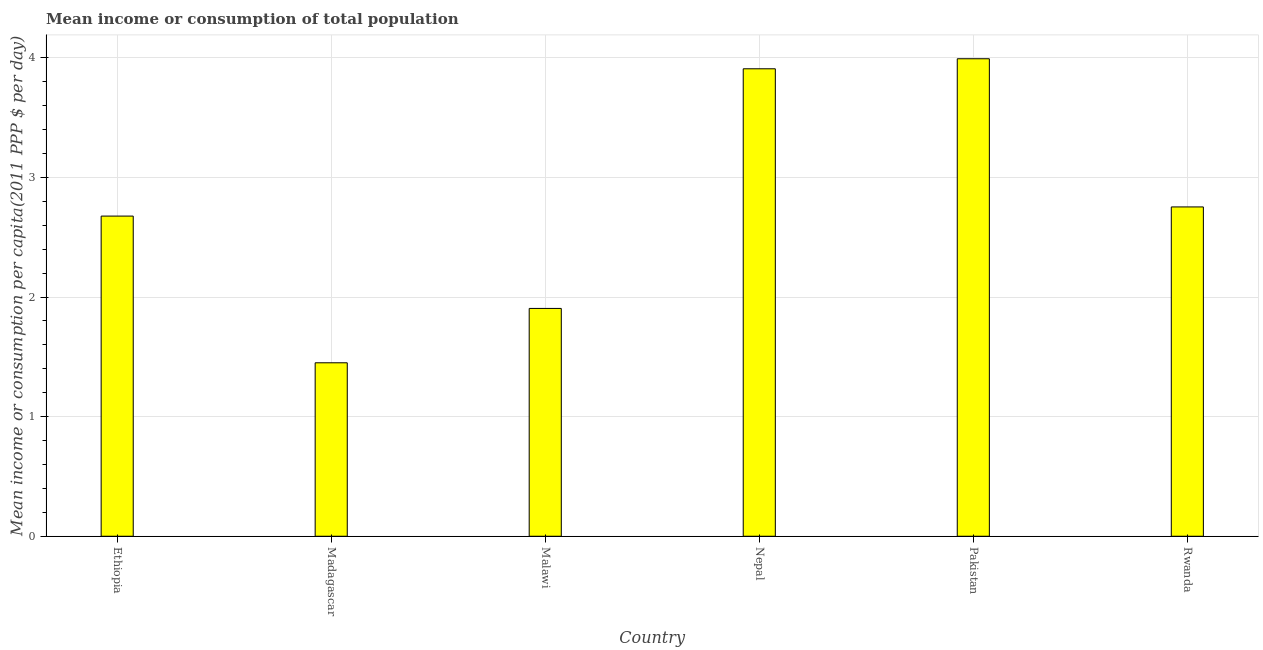Does the graph contain any zero values?
Make the answer very short. No. What is the title of the graph?
Provide a short and direct response. Mean income or consumption of total population. What is the label or title of the X-axis?
Give a very brief answer. Country. What is the label or title of the Y-axis?
Your answer should be very brief. Mean income or consumption per capita(2011 PPP $ per day). What is the mean income or consumption in Nepal?
Your response must be concise. 3.91. Across all countries, what is the maximum mean income or consumption?
Ensure brevity in your answer.  3.99. Across all countries, what is the minimum mean income or consumption?
Ensure brevity in your answer.  1.45. In which country was the mean income or consumption minimum?
Your answer should be compact. Madagascar. What is the sum of the mean income or consumption?
Ensure brevity in your answer.  16.69. What is the difference between the mean income or consumption in Nepal and Rwanda?
Provide a short and direct response. 1.16. What is the average mean income or consumption per country?
Offer a terse response. 2.78. What is the median mean income or consumption?
Make the answer very short. 2.72. What is the ratio of the mean income or consumption in Ethiopia to that in Madagascar?
Offer a terse response. 1.85. What is the difference between the highest and the second highest mean income or consumption?
Offer a terse response. 0.08. What is the difference between the highest and the lowest mean income or consumption?
Make the answer very short. 2.54. How many countries are there in the graph?
Offer a very short reply. 6. What is the difference between two consecutive major ticks on the Y-axis?
Make the answer very short. 1. Are the values on the major ticks of Y-axis written in scientific E-notation?
Your answer should be very brief. No. What is the Mean income or consumption per capita(2011 PPP $ per day) in Ethiopia?
Keep it short and to the point. 2.68. What is the Mean income or consumption per capita(2011 PPP $ per day) in Madagascar?
Your response must be concise. 1.45. What is the Mean income or consumption per capita(2011 PPP $ per day) of Malawi?
Your answer should be compact. 1.9. What is the Mean income or consumption per capita(2011 PPP $ per day) in Nepal?
Provide a succinct answer. 3.91. What is the Mean income or consumption per capita(2011 PPP $ per day) of Pakistan?
Provide a succinct answer. 3.99. What is the Mean income or consumption per capita(2011 PPP $ per day) in Rwanda?
Your answer should be very brief. 2.75. What is the difference between the Mean income or consumption per capita(2011 PPP $ per day) in Ethiopia and Madagascar?
Keep it short and to the point. 1.23. What is the difference between the Mean income or consumption per capita(2011 PPP $ per day) in Ethiopia and Malawi?
Your answer should be very brief. 0.77. What is the difference between the Mean income or consumption per capita(2011 PPP $ per day) in Ethiopia and Nepal?
Your answer should be very brief. -1.23. What is the difference between the Mean income or consumption per capita(2011 PPP $ per day) in Ethiopia and Pakistan?
Your answer should be compact. -1.32. What is the difference between the Mean income or consumption per capita(2011 PPP $ per day) in Ethiopia and Rwanda?
Keep it short and to the point. -0.08. What is the difference between the Mean income or consumption per capita(2011 PPP $ per day) in Madagascar and Malawi?
Give a very brief answer. -0.45. What is the difference between the Mean income or consumption per capita(2011 PPP $ per day) in Madagascar and Nepal?
Offer a very short reply. -2.46. What is the difference between the Mean income or consumption per capita(2011 PPP $ per day) in Madagascar and Pakistan?
Offer a terse response. -2.54. What is the difference between the Mean income or consumption per capita(2011 PPP $ per day) in Madagascar and Rwanda?
Your answer should be compact. -1.3. What is the difference between the Mean income or consumption per capita(2011 PPP $ per day) in Malawi and Nepal?
Give a very brief answer. -2. What is the difference between the Mean income or consumption per capita(2011 PPP $ per day) in Malawi and Pakistan?
Your response must be concise. -2.09. What is the difference between the Mean income or consumption per capita(2011 PPP $ per day) in Malawi and Rwanda?
Offer a very short reply. -0.85. What is the difference between the Mean income or consumption per capita(2011 PPP $ per day) in Nepal and Pakistan?
Provide a succinct answer. -0.08. What is the difference between the Mean income or consumption per capita(2011 PPP $ per day) in Nepal and Rwanda?
Provide a short and direct response. 1.15. What is the difference between the Mean income or consumption per capita(2011 PPP $ per day) in Pakistan and Rwanda?
Make the answer very short. 1.24. What is the ratio of the Mean income or consumption per capita(2011 PPP $ per day) in Ethiopia to that in Madagascar?
Make the answer very short. 1.85. What is the ratio of the Mean income or consumption per capita(2011 PPP $ per day) in Ethiopia to that in Malawi?
Ensure brevity in your answer.  1.41. What is the ratio of the Mean income or consumption per capita(2011 PPP $ per day) in Ethiopia to that in Nepal?
Your response must be concise. 0.69. What is the ratio of the Mean income or consumption per capita(2011 PPP $ per day) in Ethiopia to that in Pakistan?
Ensure brevity in your answer.  0.67. What is the ratio of the Mean income or consumption per capita(2011 PPP $ per day) in Ethiopia to that in Rwanda?
Offer a very short reply. 0.97. What is the ratio of the Mean income or consumption per capita(2011 PPP $ per day) in Madagascar to that in Malawi?
Your answer should be compact. 0.76. What is the ratio of the Mean income or consumption per capita(2011 PPP $ per day) in Madagascar to that in Nepal?
Your answer should be compact. 0.37. What is the ratio of the Mean income or consumption per capita(2011 PPP $ per day) in Madagascar to that in Pakistan?
Make the answer very short. 0.36. What is the ratio of the Mean income or consumption per capita(2011 PPP $ per day) in Madagascar to that in Rwanda?
Provide a short and direct response. 0.53. What is the ratio of the Mean income or consumption per capita(2011 PPP $ per day) in Malawi to that in Nepal?
Your answer should be very brief. 0.49. What is the ratio of the Mean income or consumption per capita(2011 PPP $ per day) in Malawi to that in Pakistan?
Provide a succinct answer. 0.48. What is the ratio of the Mean income or consumption per capita(2011 PPP $ per day) in Malawi to that in Rwanda?
Your response must be concise. 0.69. What is the ratio of the Mean income or consumption per capita(2011 PPP $ per day) in Nepal to that in Pakistan?
Make the answer very short. 0.98. What is the ratio of the Mean income or consumption per capita(2011 PPP $ per day) in Nepal to that in Rwanda?
Give a very brief answer. 1.42. What is the ratio of the Mean income or consumption per capita(2011 PPP $ per day) in Pakistan to that in Rwanda?
Make the answer very short. 1.45. 